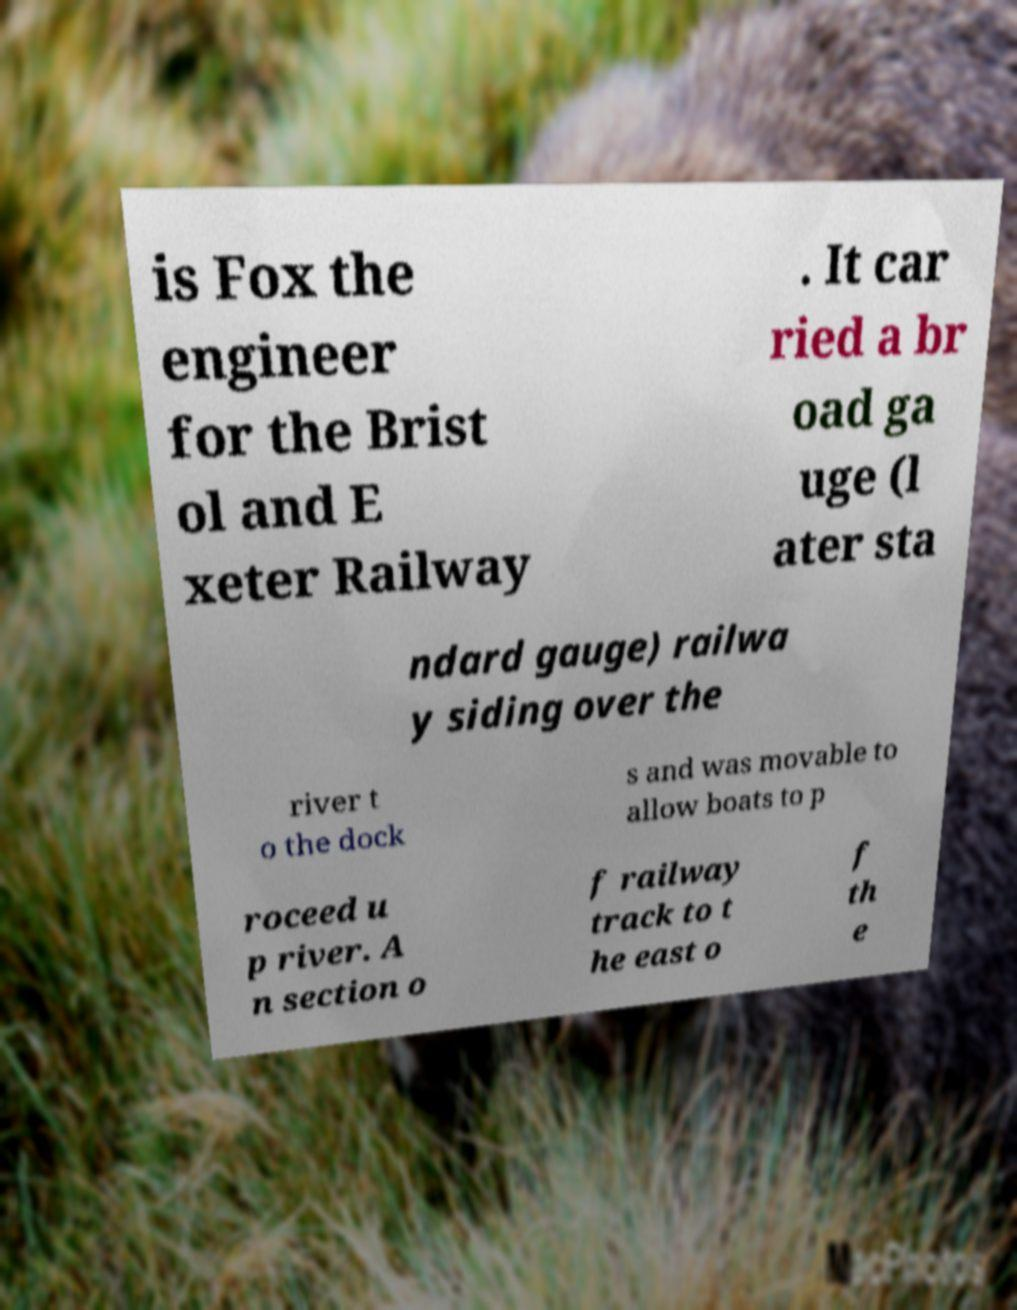For documentation purposes, I need the text within this image transcribed. Could you provide that? is Fox the engineer for the Brist ol and E xeter Railway . It car ried a br oad ga uge (l ater sta ndard gauge) railwa y siding over the river t o the dock s and was movable to allow boats to p roceed u p river. A n section o f railway track to t he east o f th e 